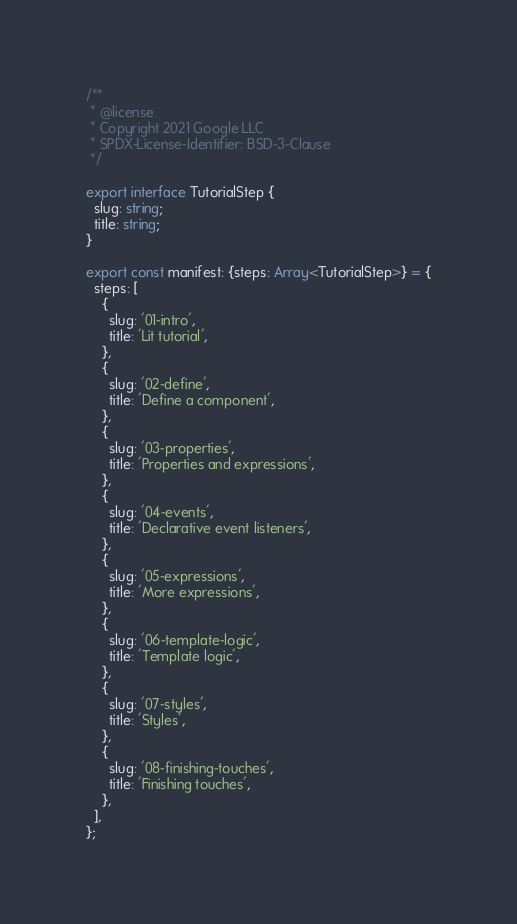Convert code to text. <code><loc_0><loc_0><loc_500><loc_500><_TypeScript_>/**
 * @license
 * Copyright 2021 Google LLC
 * SPDX-License-Identifier: BSD-3-Clause
 */

export interface TutorialStep {
  slug: string;
  title: string;
}

export const manifest: {steps: Array<TutorialStep>} = {
  steps: [
    {
      slug: '01-intro',
      title: 'Lit tutorial',
    },
    {
      slug: '02-define',
      title: 'Define a component',
    },
    {
      slug: '03-properties',
      title: 'Properties and expressions',
    },
    {
      slug: '04-events',
      title: 'Declarative event listeners',
    },
    {
      slug: '05-expressions',
      title: 'More expressions',
    },
    {
      slug: '06-template-logic',
      title: 'Template logic',
    },
    {
      slug: '07-styles',
      title: 'Styles',
    },
    {
      slug: '08-finishing-touches',
      title: 'Finishing touches',
    },
  ],
};
</code> 